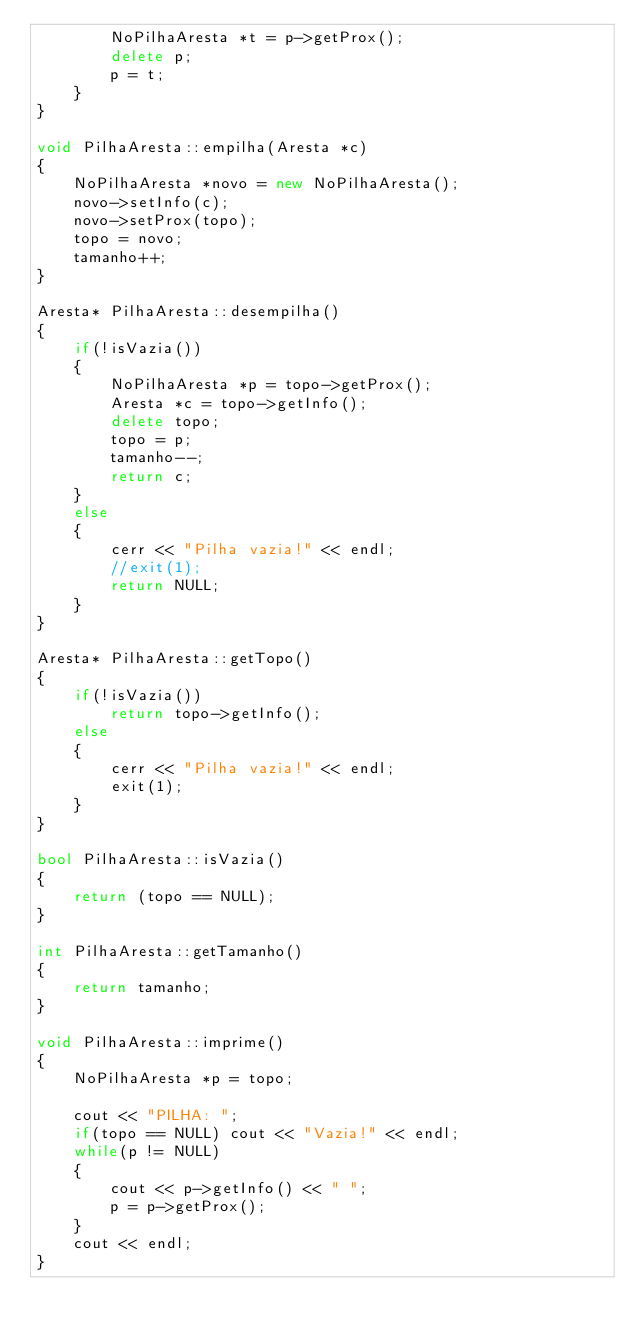Convert code to text. <code><loc_0><loc_0><loc_500><loc_500><_C++_>        NoPilhaAresta *t = p->getProx();
        delete p;
        p = t;
    }
}

void PilhaAresta::empilha(Aresta *c)
{
    NoPilhaAresta *novo = new NoPilhaAresta();
    novo->setInfo(c);
    novo->setProx(topo);
    topo = novo;
    tamanho++;
}

Aresta* PilhaAresta::desempilha()
{
    if(!isVazia())
    {
        NoPilhaAresta *p = topo->getProx();
        Aresta *c = topo->getInfo();
        delete topo;
        topo = p;
        tamanho--;
        return c;
    }
    else
    {
        cerr << "Pilha vazia!" << endl;
        //exit(1);
        return NULL;
    }
}

Aresta* PilhaAresta::getTopo()
{
    if(!isVazia())
        return topo->getInfo();
    else
    {
        cerr << "Pilha vazia!" << endl;
        exit(1);
    }
}

bool PilhaAresta::isVazia()
{
    return (topo == NULL);
}

int PilhaAresta::getTamanho()
{
    return tamanho;
}

void PilhaAresta::imprime()
{
    NoPilhaAresta *p = topo;

    cout << "PILHA: ";
    if(topo == NULL) cout << "Vazia!" << endl;
    while(p != NULL)
    {
        cout << p->getInfo() << " ";
        p = p->getProx();
    }
    cout << endl;
}
</code> 